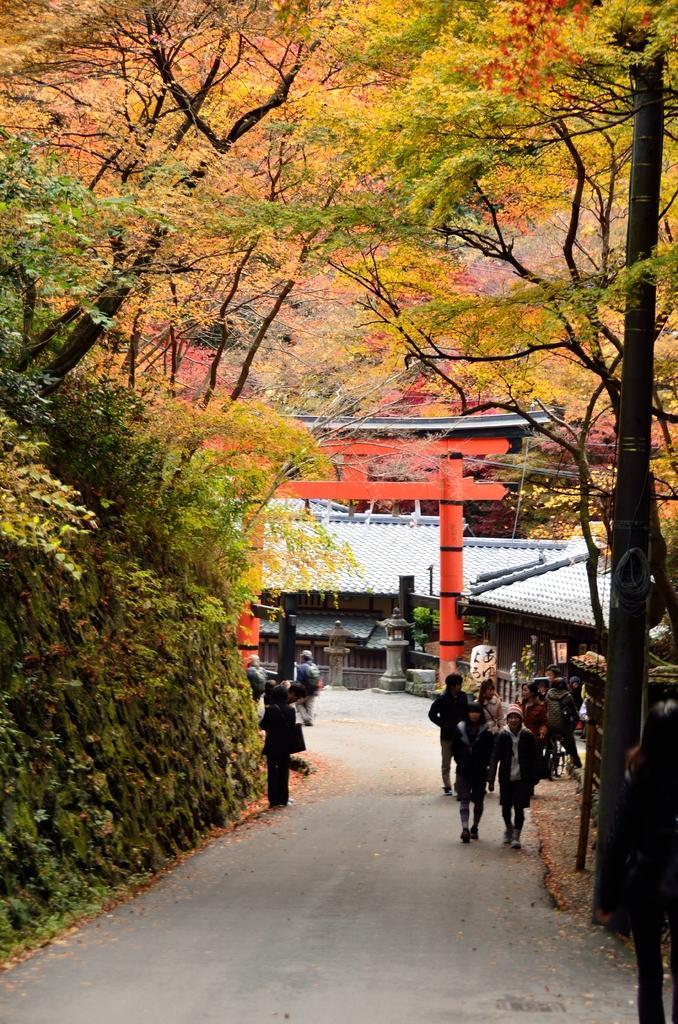Describe this image in one or two sentences. In this image I can see trees, buildings and people walking on the road. I can also see poles and some other objects beside the road. 